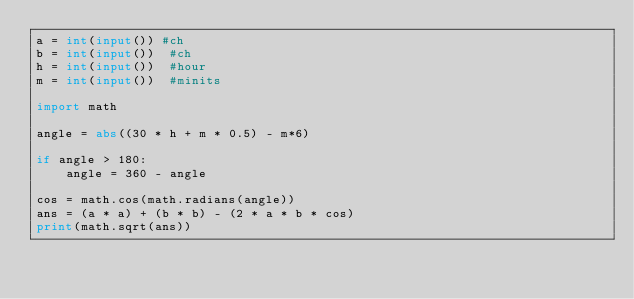Convert code to text. <code><loc_0><loc_0><loc_500><loc_500><_Python_>a = int(input()) #ch
b = int(input())  #ch
h = int(input())  #hour
m = int(input())  #minits

import math

angle = abs((30 * h + m * 0.5) - m*6)

if angle > 180:
    angle = 360 - angle

cos = math.cos(math.radians(angle))
ans = (a * a) + (b * b) - (2 * a * b * cos)
print(math.sqrt(ans))
</code> 